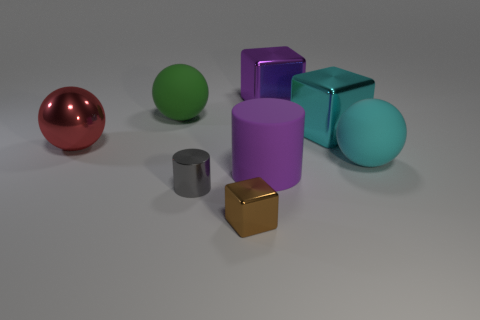How many other objects are the same material as the brown block?
Your answer should be compact. 4. How many small metal blocks are left of the small gray metal thing?
Offer a terse response. 0. Is there a blue sphere made of the same material as the brown thing?
Your response must be concise. No. Is the number of metallic objects behind the small metal block greater than the number of metallic cubes that are behind the big cyan matte thing?
Make the answer very short. Yes. The red object has what size?
Provide a succinct answer. Large. The tiny metal object behind the tiny cube has what shape?
Ensure brevity in your answer.  Cylinder. Is the shape of the green object the same as the gray metallic thing?
Offer a terse response. No. Are there the same number of large purple metal things that are left of the large cylinder and large cyan rubber balls?
Make the answer very short. No. The cyan shiny object is what shape?
Your answer should be very brief. Cube. Is there any other thing of the same color as the shiny cylinder?
Provide a short and direct response. No. 